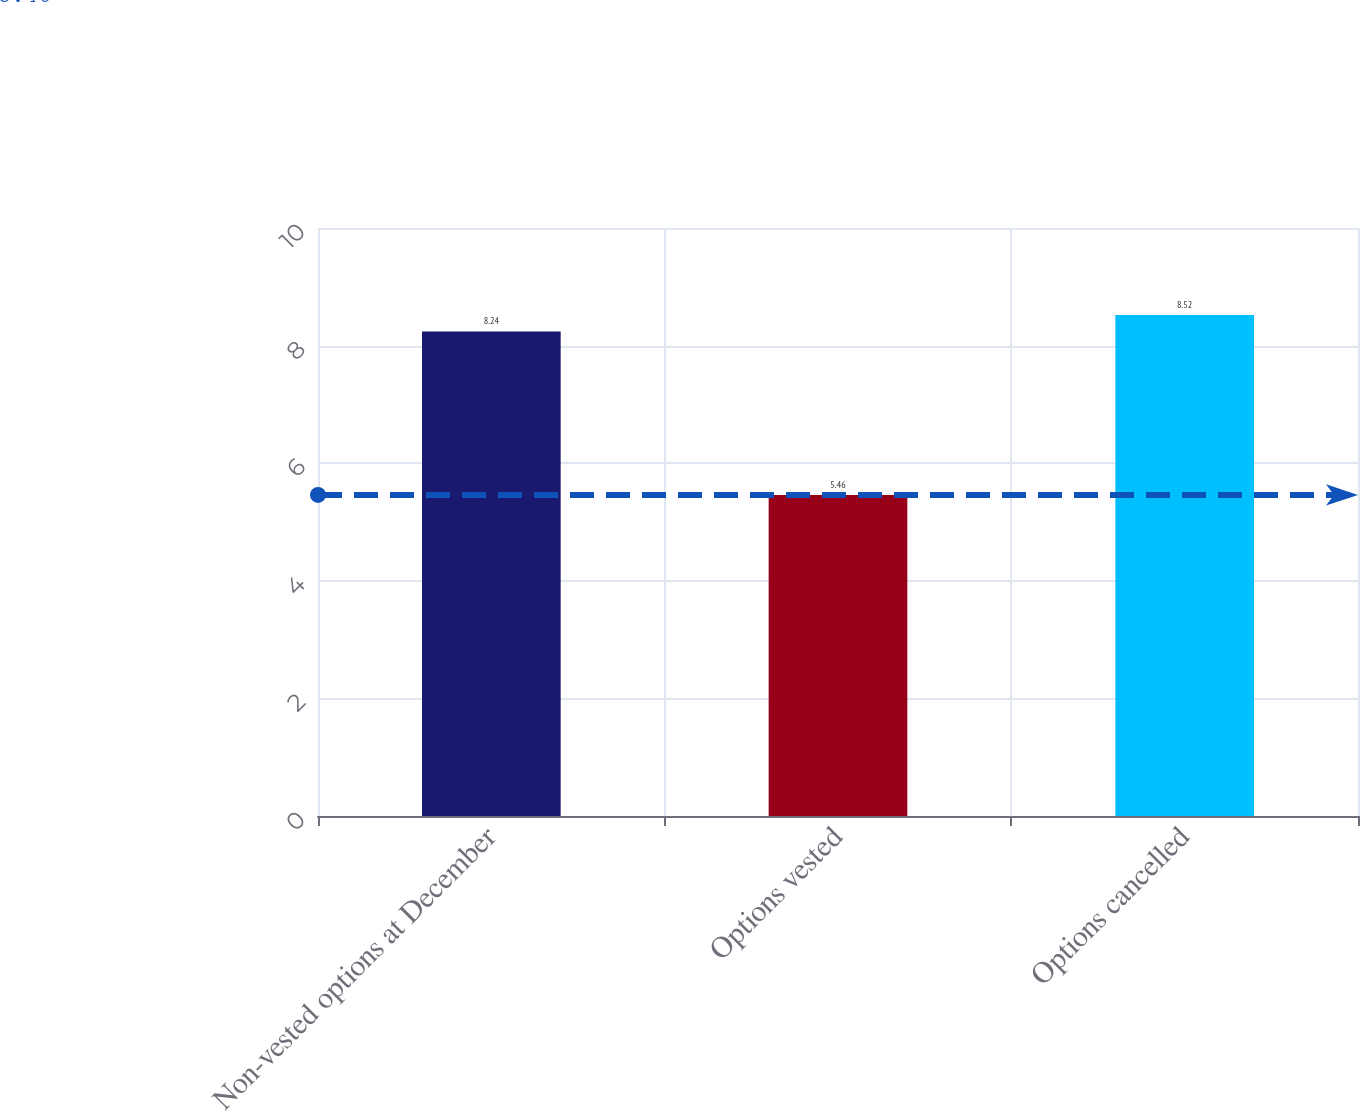Convert chart to OTSL. <chart><loc_0><loc_0><loc_500><loc_500><bar_chart><fcel>Non-vested options at December<fcel>Options vested<fcel>Options cancelled<nl><fcel>8.24<fcel>5.46<fcel>8.52<nl></chart> 